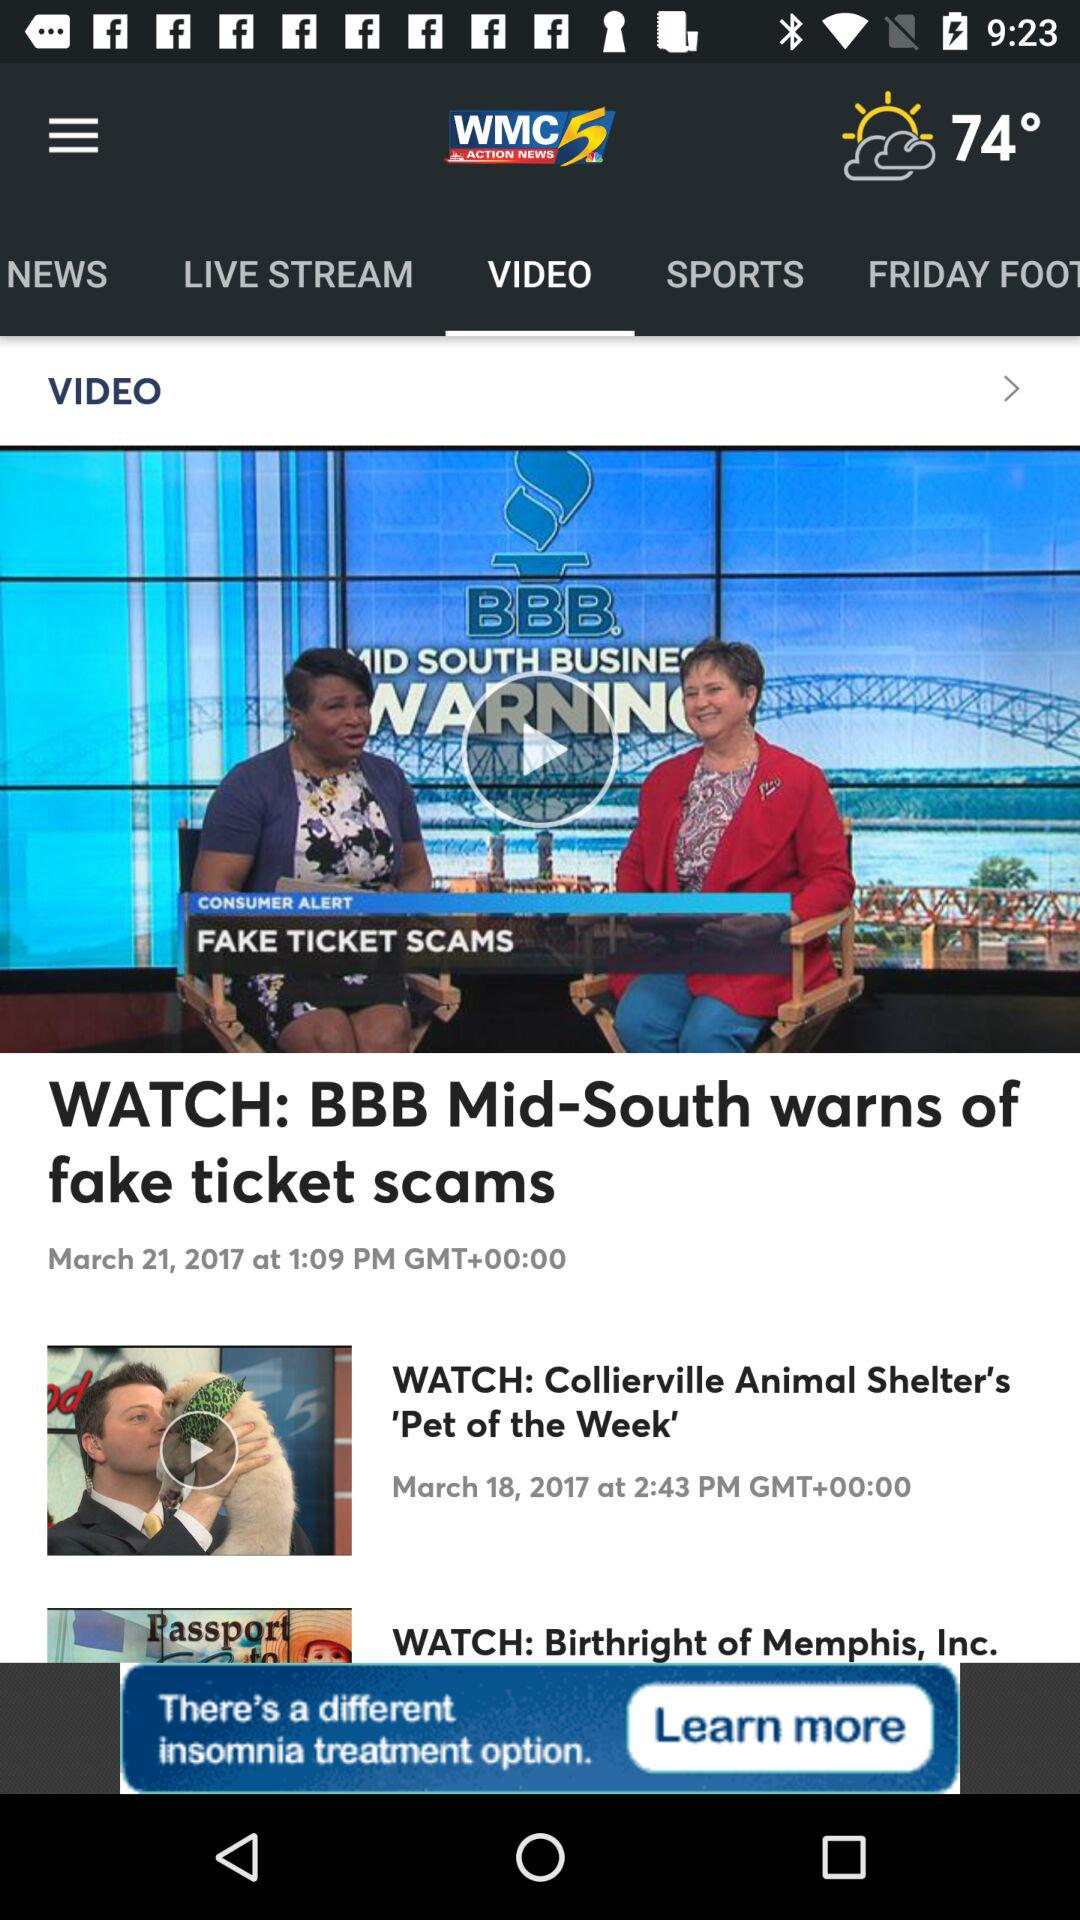What is the temperature? The temperature is 74°. 